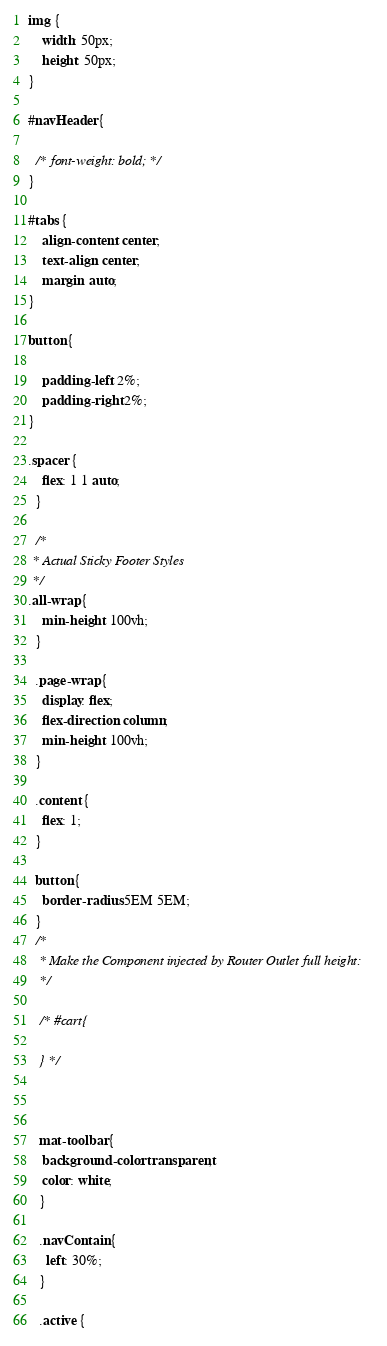<code> <loc_0><loc_0><loc_500><loc_500><_CSS_>img {
    width: 50px;
    height: 50px;
}

#navHeader {
  
  /* font-weight: bold; */
}

#tabs {
    align-content: center;
    text-align: center;
    margin: auto;
}

button {

    padding-left: 2%;
    padding-right: 2%;
}

.spacer {
    flex: 1 1 auto;
  }

  /*
 * Actual Sticky Footer Styles
 */
.all-wrap {
    min-height: 100vh;
  }
  
  .page-wrap {
    display: flex;
    flex-direction: column;
    min-height: 100vh;
  }
  
  .content {
    flex: 1;
  }
  
  button {
    border-radius: 5EM 5EM;
  }
  /*
   * Make the Component injected by Router Outlet full height:
   */

   /* #cart{

   } */



   mat-toolbar {
    background-color: transparent;
    color: white;
   }

   .navContain {
     left: 30%;
   }

   .active {</code> 